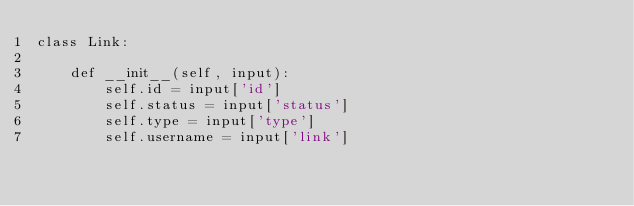Convert code to text. <code><loc_0><loc_0><loc_500><loc_500><_Python_>class Link:

    def __init__(self, input):
        self.id = input['id']
        self.status = input['status']
        self.type = input['type']
        self.username = input['link']
</code> 